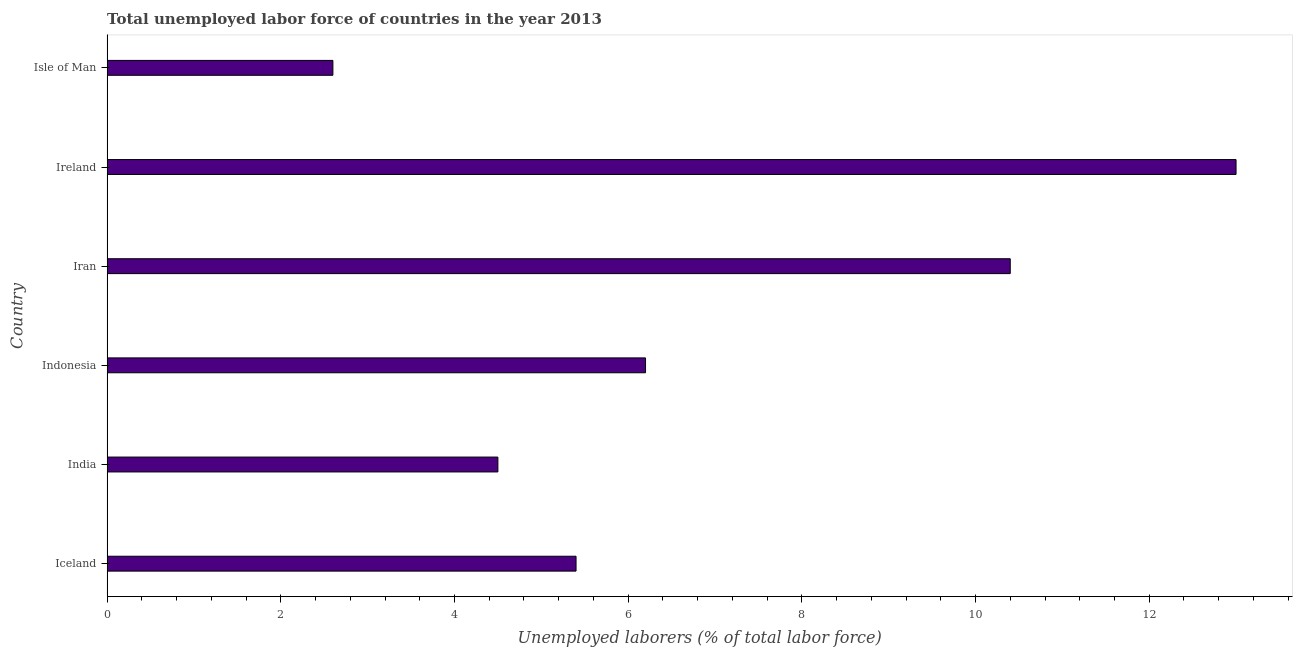What is the title of the graph?
Offer a very short reply. Total unemployed labor force of countries in the year 2013. What is the label or title of the X-axis?
Provide a succinct answer. Unemployed laborers (% of total labor force). What is the label or title of the Y-axis?
Offer a very short reply. Country. What is the total unemployed labour force in Iceland?
Offer a terse response. 5.4. Across all countries, what is the maximum total unemployed labour force?
Keep it short and to the point. 13. Across all countries, what is the minimum total unemployed labour force?
Provide a short and direct response. 2.6. In which country was the total unemployed labour force maximum?
Provide a short and direct response. Ireland. In which country was the total unemployed labour force minimum?
Your answer should be compact. Isle of Man. What is the sum of the total unemployed labour force?
Your answer should be compact. 42.1. What is the average total unemployed labour force per country?
Make the answer very short. 7.02. What is the median total unemployed labour force?
Your answer should be very brief. 5.8. What is the ratio of the total unemployed labour force in India to that in Ireland?
Give a very brief answer. 0.35. What is the difference between the highest and the lowest total unemployed labour force?
Offer a very short reply. 10.4. In how many countries, is the total unemployed labour force greater than the average total unemployed labour force taken over all countries?
Give a very brief answer. 2. How many countries are there in the graph?
Your answer should be very brief. 6. What is the difference between two consecutive major ticks on the X-axis?
Your response must be concise. 2. What is the Unemployed laborers (% of total labor force) of Iceland?
Your response must be concise. 5.4. What is the Unemployed laborers (% of total labor force) of Indonesia?
Your answer should be compact. 6.2. What is the Unemployed laborers (% of total labor force) of Iran?
Give a very brief answer. 10.4. What is the Unemployed laborers (% of total labor force) in Ireland?
Your answer should be compact. 13. What is the Unemployed laborers (% of total labor force) of Isle of Man?
Your answer should be very brief. 2.6. What is the difference between the Unemployed laborers (% of total labor force) in Iceland and India?
Provide a succinct answer. 0.9. What is the difference between the Unemployed laborers (% of total labor force) in Iceland and Indonesia?
Offer a terse response. -0.8. What is the difference between the Unemployed laborers (% of total labor force) in Iceland and Iran?
Offer a terse response. -5. What is the difference between the Unemployed laborers (% of total labor force) in Iceland and Ireland?
Keep it short and to the point. -7.6. What is the difference between the Unemployed laborers (% of total labor force) in India and Indonesia?
Make the answer very short. -1.7. What is the difference between the Unemployed laborers (% of total labor force) in India and Iran?
Keep it short and to the point. -5.9. What is the difference between the Unemployed laborers (% of total labor force) in India and Isle of Man?
Keep it short and to the point. 1.9. What is the difference between the Unemployed laborers (% of total labor force) in Indonesia and Iran?
Give a very brief answer. -4.2. What is the difference between the Unemployed laborers (% of total labor force) in Iran and Isle of Man?
Your answer should be compact. 7.8. What is the ratio of the Unemployed laborers (% of total labor force) in Iceland to that in Indonesia?
Your answer should be compact. 0.87. What is the ratio of the Unemployed laborers (% of total labor force) in Iceland to that in Iran?
Provide a succinct answer. 0.52. What is the ratio of the Unemployed laborers (% of total labor force) in Iceland to that in Ireland?
Make the answer very short. 0.41. What is the ratio of the Unemployed laborers (% of total labor force) in Iceland to that in Isle of Man?
Your answer should be very brief. 2.08. What is the ratio of the Unemployed laborers (% of total labor force) in India to that in Indonesia?
Ensure brevity in your answer.  0.73. What is the ratio of the Unemployed laborers (% of total labor force) in India to that in Iran?
Your answer should be compact. 0.43. What is the ratio of the Unemployed laborers (% of total labor force) in India to that in Ireland?
Offer a terse response. 0.35. What is the ratio of the Unemployed laborers (% of total labor force) in India to that in Isle of Man?
Give a very brief answer. 1.73. What is the ratio of the Unemployed laborers (% of total labor force) in Indonesia to that in Iran?
Your answer should be very brief. 0.6. What is the ratio of the Unemployed laborers (% of total labor force) in Indonesia to that in Ireland?
Make the answer very short. 0.48. What is the ratio of the Unemployed laborers (% of total labor force) in Indonesia to that in Isle of Man?
Your answer should be compact. 2.38. What is the ratio of the Unemployed laborers (% of total labor force) in Iran to that in Ireland?
Make the answer very short. 0.8. What is the ratio of the Unemployed laborers (% of total labor force) in Iran to that in Isle of Man?
Your answer should be very brief. 4. What is the ratio of the Unemployed laborers (% of total labor force) in Ireland to that in Isle of Man?
Make the answer very short. 5. 